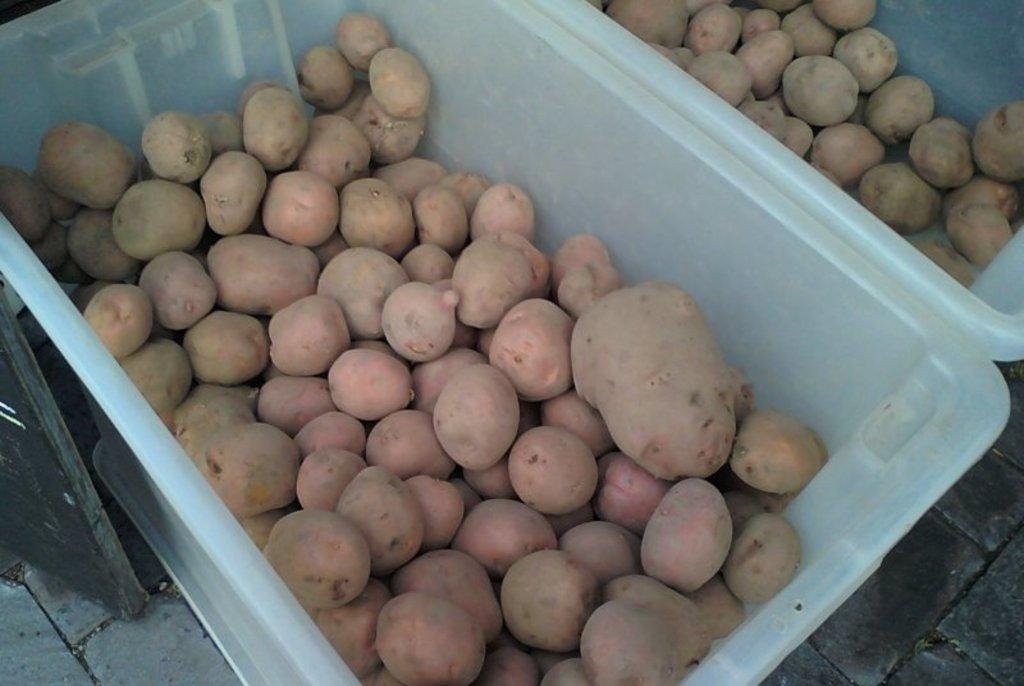What type of vegetable is present in the trays in the image? There are potatoes in the trays in the image. What other object can be seen in the image besides the potatoes? There is another object in the image, but its description is not provided in the facts. What surface is visible at the bottom of the image? There is a floor visible at the bottom of the image. What type of dirt can be seen on the cars in the image? There are no cars present in the image, so it is not possible to determine if there is any dirt on them. 